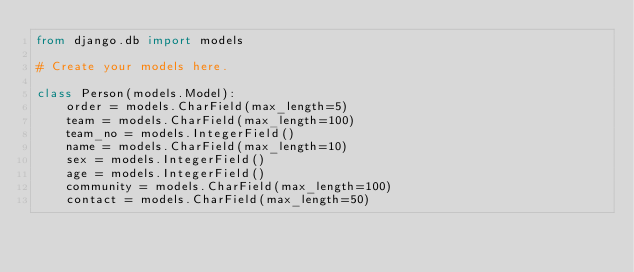<code> <loc_0><loc_0><loc_500><loc_500><_Python_>from django.db import models

# Create your models here.

class Person(models.Model):
    order = models.CharField(max_length=5)
    team = models.CharField(max_length=100)
    team_no = models.IntegerField()
    name = models.CharField(max_length=10)
    sex = models.IntegerField()
    age = models.IntegerField()
    community = models.CharField(max_length=100)
    contact = models.CharField(max_length=50)
</code> 